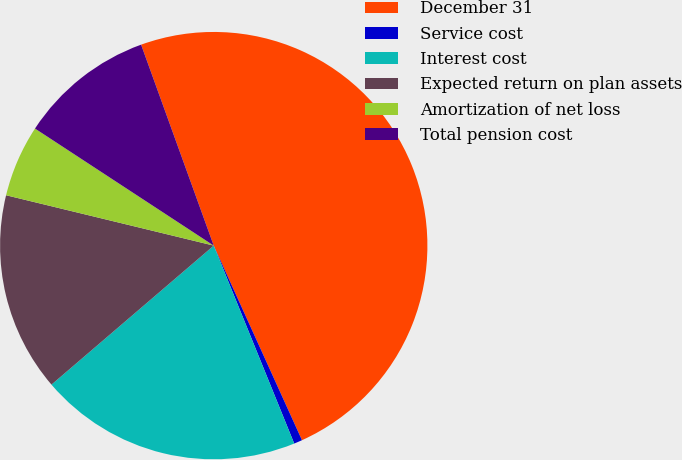Convert chart. <chart><loc_0><loc_0><loc_500><loc_500><pie_chart><fcel>December 31<fcel>Service cost<fcel>Interest cost<fcel>Expected return on plan assets<fcel>Amortization of net loss<fcel>Total pension cost<nl><fcel>48.74%<fcel>0.63%<fcel>19.87%<fcel>15.06%<fcel>5.44%<fcel>10.25%<nl></chart> 